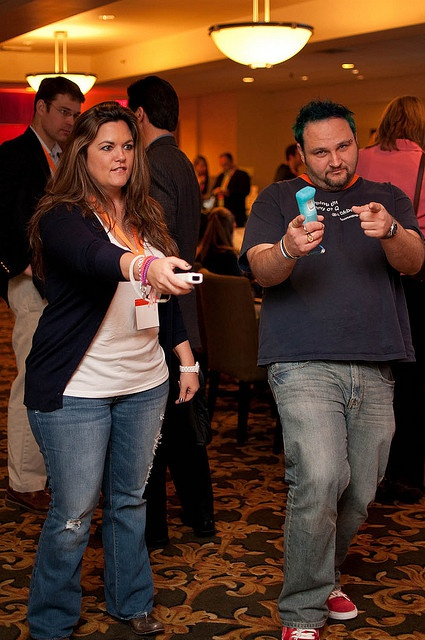Describe the objects in this image and their specific colors. I can see people in maroon, black, gray, and darkblue tones, people in maroon, black, gray, and brown tones, people in maroon, black, brown, and gray tones, people in maroon, black, and gray tones, and chair in maroon, black, and brown tones in this image. 